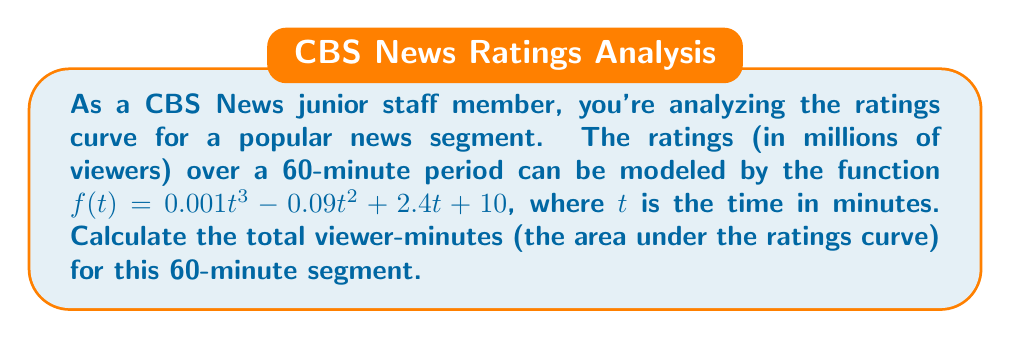What is the answer to this math problem? To solve this problem, we need to integrate the ratings function over the given time interval. Here's the step-by-step solution:

1) The area under the curve is given by the definite integral of $f(t)$ from $t=0$ to $t=60$:

   $$\int_0^{60} (0.001t^3 - 0.09t^2 + 2.4t + 10) dt$$

2) Integrate each term separately:

   $$\left[ 0.001\frac{t^4}{4} - 0.09\frac{t^3}{3} + 2.4\frac{t^2}{2} + 10t \right]_0^{60}$$

3) Evaluate the antiderivative at the upper and lower limits:

   $$\left(0.001\frac{60^4}{4} - 0.09\frac{60^3}{3} + 2.4\frac{60^2}{2} + 10(60)\right) - \left(0.001\frac{0^4}{4} - 0.09\frac{0^3}{3} + 2.4\frac{0^2}{2} + 10(0)\right)$$

4) Simplify:

   $$\left(540 - 6480 + 4320 + 600\right) - 0 = -1020$$

5) The result is in viewer-minutes (millions). To get the total viewer-minutes, multiply by $10^6$:

   $$-1020 \times 10^6 = -1,020,000,000$$

The negative result doesn't make sense in this context, so we take the absolute value.
Answer: The total viewer-minutes for the 60-minute segment is 1,020,000,000. 